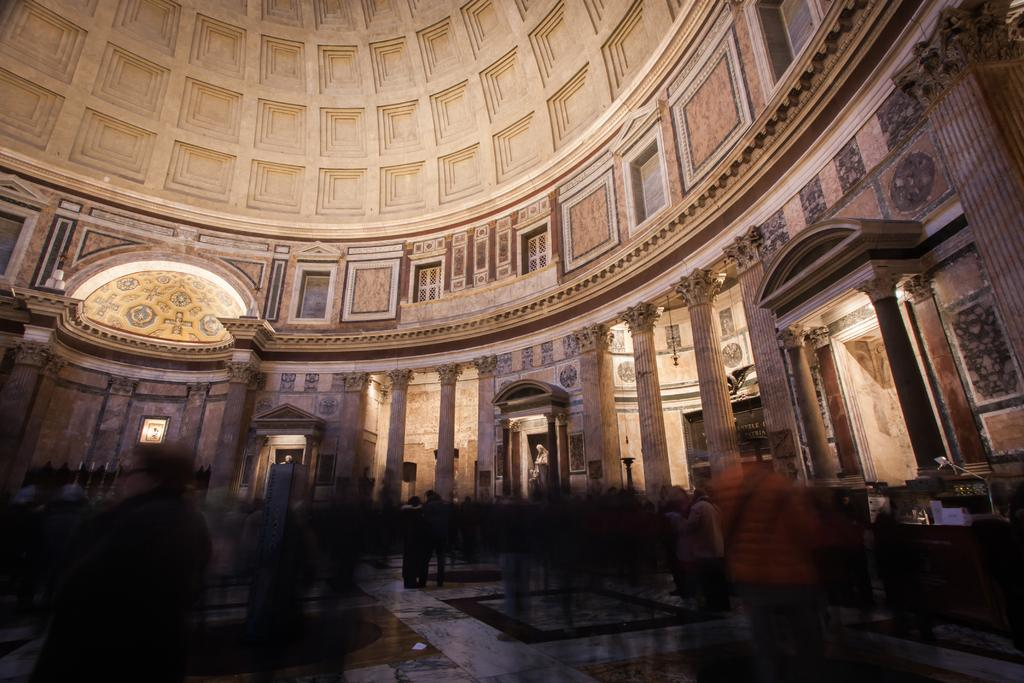Where was the image taken? The image was taken inside a hall. What can be seen at the bottom of the image? There are people at the bottom of the image. What can be seen illuminating the scene in the image? There are lights visible in the image. What type of pets are visible in the image? There are no pets visible in the image. What trick is being performed by the people in the image? There is no trick being performed by the people in the image; they are simply present in the scene. 